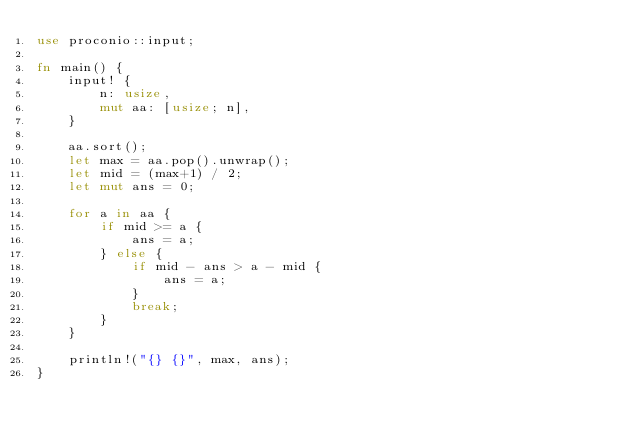Convert code to text. <code><loc_0><loc_0><loc_500><loc_500><_Rust_>use proconio::input;

fn main() {
    input! {
        n: usize,
        mut aa: [usize; n],
    }

    aa.sort();
    let max = aa.pop().unwrap();
    let mid = (max+1) / 2;
    let mut ans = 0;

    for a in aa {
        if mid >= a {
            ans = a;
        } else {
            if mid - ans > a - mid {
                ans = a;
            }
            break;
        }
    }

    println!("{} {}", max, ans);
}
</code> 